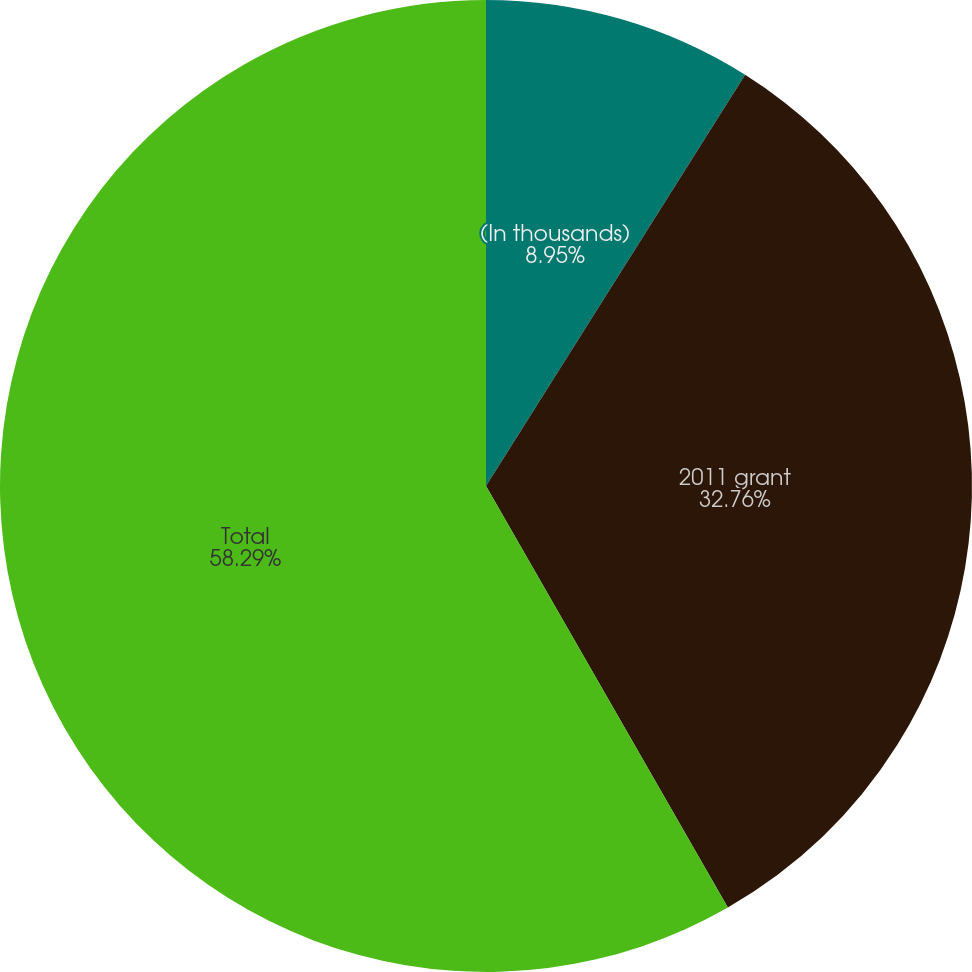<chart> <loc_0><loc_0><loc_500><loc_500><pie_chart><fcel>(In thousands)<fcel>2011 grant<fcel>Total<nl><fcel>8.95%<fcel>32.76%<fcel>58.29%<nl></chart> 